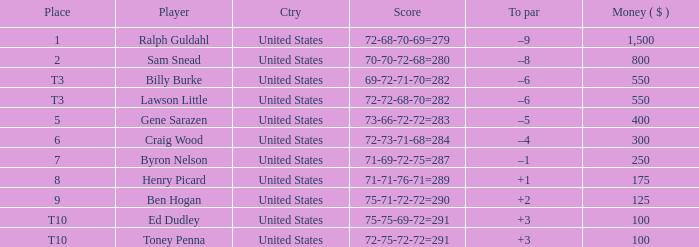Which country has a prize smaller than $250 and the player Henry Picard? United States. 